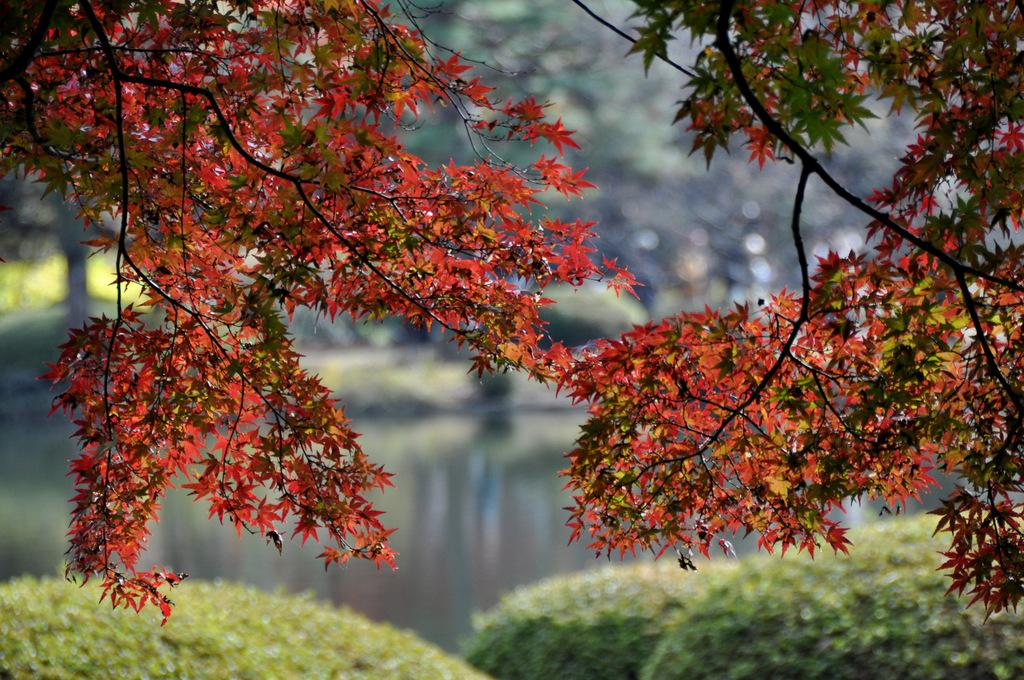What type of natural elements can be seen in the image? There are trees and water visible in the image. Can you describe the background of the image? The background of the image appears blurry. Where is the shelf located in the image? There is no shelf present in the image. What type of poison can be seen in the image? There is no poison present in the image. 